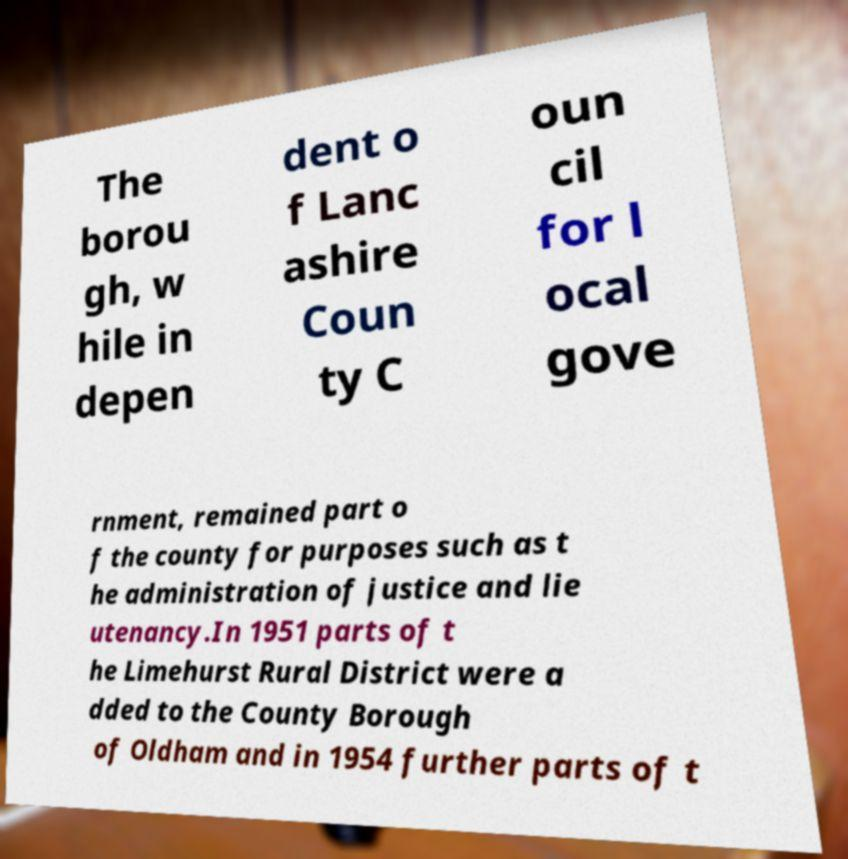What messages or text are displayed in this image? I need them in a readable, typed format. The borou gh, w hile in depen dent o f Lanc ashire Coun ty C oun cil for l ocal gove rnment, remained part o f the county for purposes such as t he administration of justice and lie utenancy.In 1951 parts of t he Limehurst Rural District were a dded to the County Borough of Oldham and in 1954 further parts of t 